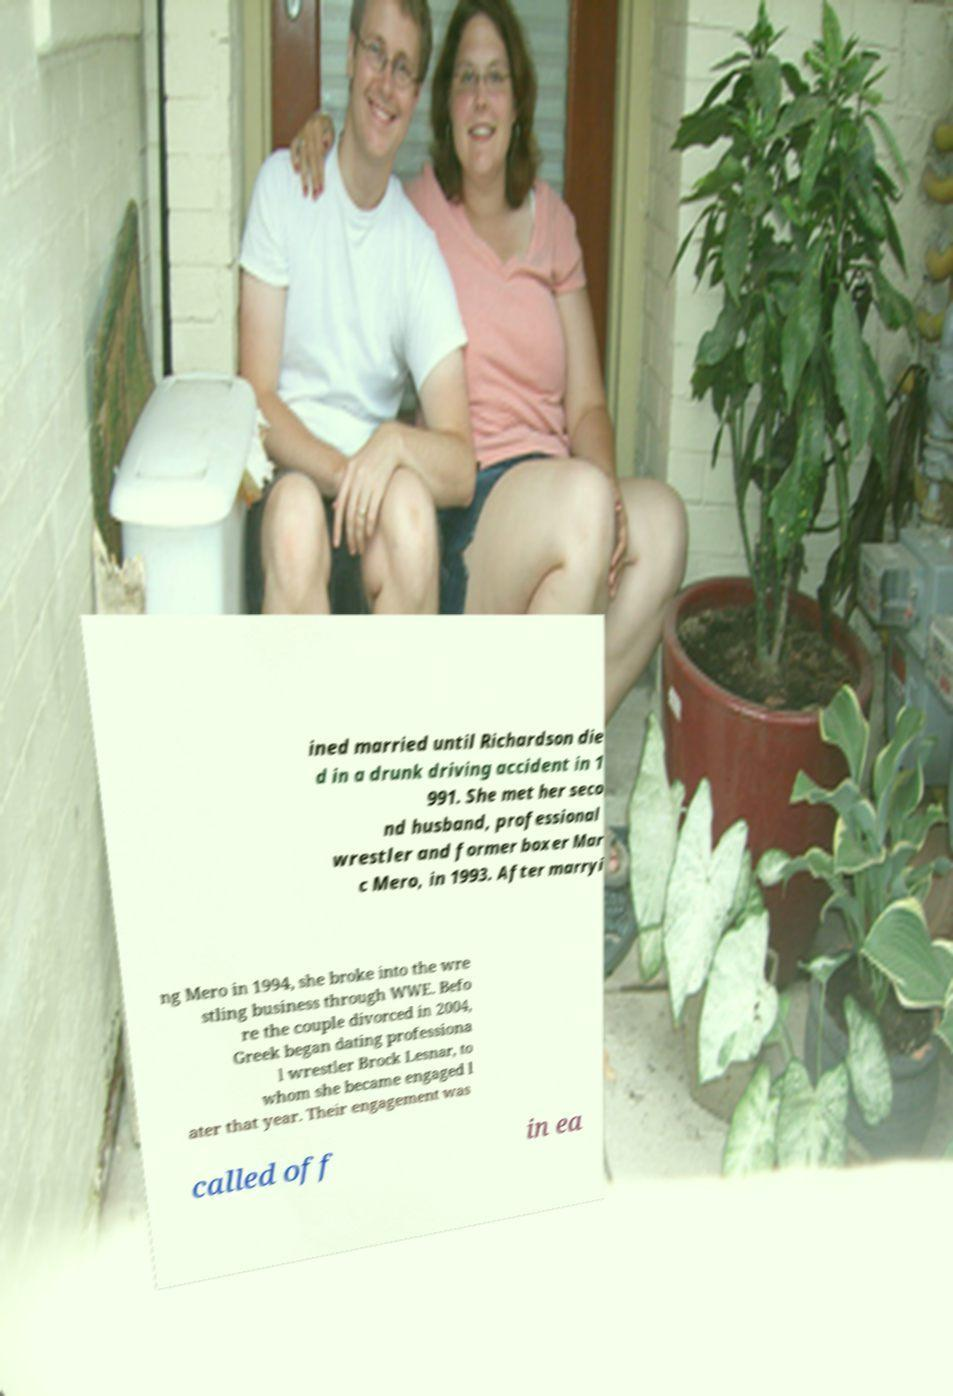Could you assist in decoding the text presented in this image and type it out clearly? ined married until Richardson die d in a drunk driving accident in 1 991. She met her seco nd husband, professional wrestler and former boxer Mar c Mero, in 1993. After marryi ng Mero in 1994, she broke into the wre stling business through WWE. Befo re the couple divorced in 2004, Greek began dating professiona l wrestler Brock Lesnar, to whom she became engaged l ater that year. Their engagement was called off in ea 